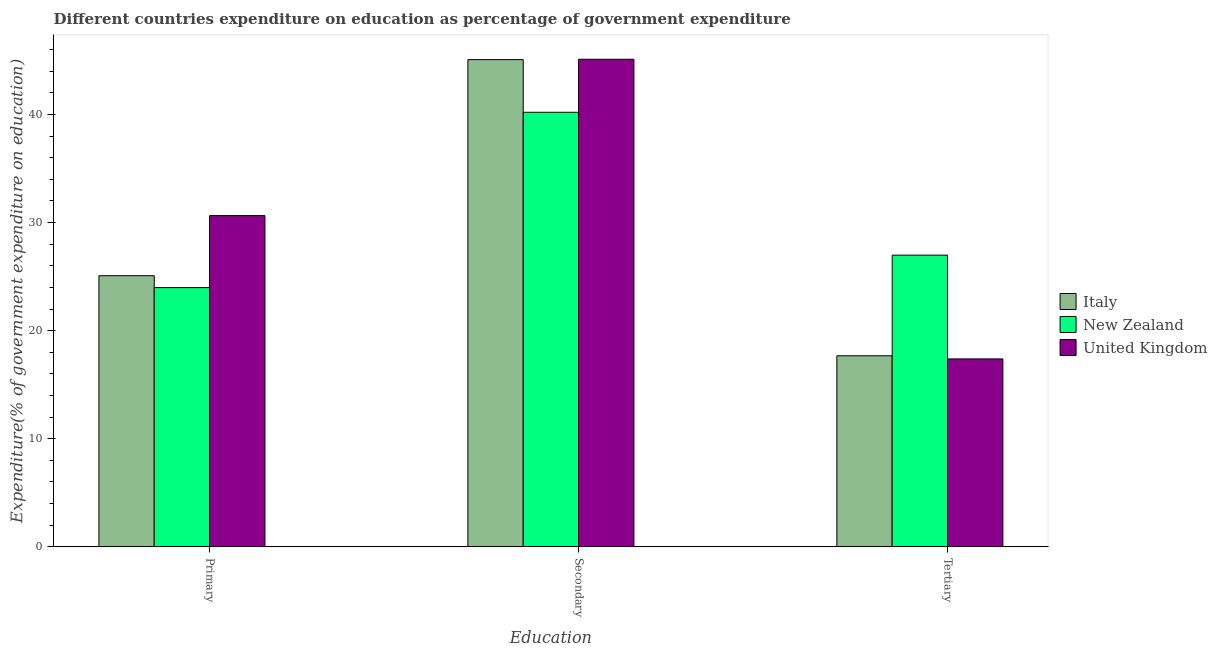How many different coloured bars are there?
Provide a short and direct response. 3. How many groups of bars are there?
Make the answer very short. 3. Are the number of bars on each tick of the X-axis equal?
Give a very brief answer. Yes. What is the label of the 2nd group of bars from the left?
Make the answer very short. Secondary. What is the expenditure on secondary education in United Kingdom?
Ensure brevity in your answer.  45.11. Across all countries, what is the maximum expenditure on secondary education?
Ensure brevity in your answer.  45.11. Across all countries, what is the minimum expenditure on primary education?
Offer a terse response. 23.99. In which country was the expenditure on tertiary education maximum?
Give a very brief answer. New Zealand. In which country was the expenditure on primary education minimum?
Your answer should be compact. New Zealand. What is the total expenditure on secondary education in the graph?
Provide a succinct answer. 130.39. What is the difference between the expenditure on tertiary education in Italy and that in New Zealand?
Ensure brevity in your answer.  -9.31. What is the difference between the expenditure on secondary education in Italy and the expenditure on tertiary education in New Zealand?
Offer a very short reply. 18.09. What is the average expenditure on secondary education per country?
Ensure brevity in your answer.  43.46. What is the difference between the expenditure on primary education and expenditure on tertiary education in Italy?
Provide a short and direct response. 7.41. In how many countries, is the expenditure on primary education greater than 32 %?
Offer a very short reply. 0. What is the ratio of the expenditure on secondary education in United Kingdom to that in New Zealand?
Give a very brief answer. 1.12. Is the difference between the expenditure on secondary education in Italy and United Kingdom greater than the difference between the expenditure on primary education in Italy and United Kingdom?
Your answer should be compact. Yes. What is the difference between the highest and the second highest expenditure on primary education?
Give a very brief answer. 5.56. What is the difference between the highest and the lowest expenditure on secondary education?
Offer a very short reply. 4.91. In how many countries, is the expenditure on primary education greater than the average expenditure on primary education taken over all countries?
Give a very brief answer. 1. Is the sum of the expenditure on secondary education in United Kingdom and Italy greater than the maximum expenditure on tertiary education across all countries?
Your response must be concise. Yes. What does the 3rd bar from the left in Secondary represents?
Make the answer very short. United Kingdom. How many bars are there?
Make the answer very short. 9. Are all the bars in the graph horizontal?
Your answer should be compact. No. How many countries are there in the graph?
Give a very brief answer. 3. What is the difference between two consecutive major ticks on the Y-axis?
Make the answer very short. 10. Does the graph contain any zero values?
Offer a terse response. No. Does the graph contain grids?
Your answer should be very brief. No. How many legend labels are there?
Your answer should be very brief. 3. What is the title of the graph?
Your response must be concise. Different countries expenditure on education as percentage of government expenditure. Does "Argentina" appear as one of the legend labels in the graph?
Provide a succinct answer. No. What is the label or title of the X-axis?
Your response must be concise. Education. What is the label or title of the Y-axis?
Keep it short and to the point. Expenditure(% of government expenditure on education). What is the Expenditure(% of government expenditure on education) of Italy in Primary?
Keep it short and to the point. 25.08. What is the Expenditure(% of government expenditure on education) in New Zealand in Primary?
Your answer should be very brief. 23.99. What is the Expenditure(% of government expenditure on education) of United Kingdom in Primary?
Ensure brevity in your answer.  30.65. What is the Expenditure(% of government expenditure on education) of Italy in Secondary?
Keep it short and to the point. 45.07. What is the Expenditure(% of government expenditure on education) in New Zealand in Secondary?
Offer a very short reply. 40.2. What is the Expenditure(% of government expenditure on education) of United Kingdom in Secondary?
Provide a short and direct response. 45.11. What is the Expenditure(% of government expenditure on education) in Italy in Tertiary?
Your answer should be compact. 17.68. What is the Expenditure(% of government expenditure on education) in New Zealand in Tertiary?
Make the answer very short. 26.99. What is the Expenditure(% of government expenditure on education) of United Kingdom in Tertiary?
Ensure brevity in your answer.  17.39. Across all Education, what is the maximum Expenditure(% of government expenditure on education) in Italy?
Offer a very short reply. 45.07. Across all Education, what is the maximum Expenditure(% of government expenditure on education) in New Zealand?
Give a very brief answer. 40.2. Across all Education, what is the maximum Expenditure(% of government expenditure on education) of United Kingdom?
Keep it short and to the point. 45.11. Across all Education, what is the minimum Expenditure(% of government expenditure on education) in Italy?
Provide a succinct answer. 17.68. Across all Education, what is the minimum Expenditure(% of government expenditure on education) of New Zealand?
Your answer should be compact. 23.99. Across all Education, what is the minimum Expenditure(% of government expenditure on education) in United Kingdom?
Your response must be concise. 17.39. What is the total Expenditure(% of government expenditure on education) of Italy in the graph?
Your answer should be very brief. 87.84. What is the total Expenditure(% of government expenditure on education) of New Zealand in the graph?
Your answer should be compact. 91.17. What is the total Expenditure(% of government expenditure on education) of United Kingdom in the graph?
Make the answer very short. 93.14. What is the difference between the Expenditure(% of government expenditure on education) of Italy in Primary and that in Secondary?
Provide a short and direct response. -19.99. What is the difference between the Expenditure(% of government expenditure on education) of New Zealand in Primary and that in Secondary?
Make the answer very short. -16.22. What is the difference between the Expenditure(% of government expenditure on education) of United Kingdom in Primary and that in Secondary?
Provide a succinct answer. -14.46. What is the difference between the Expenditure(% of government expenditure on education) in Italy in Primary and that in Tertiary?
Provide a short and direct response. 7.41. What is the difference between the Expenditure(% of government expenditure on education) of United Kingdom in Primary and that in Tertiary?
Your response must be concise. 13.26. What is the difference between the Expenditure(% of government expenditure on education) of Italy in Secondary and that in Tertiary?
Offer a very short reply. 27.4. What is the difference between the Expenditure(% of government expenditure on education) in New Zealand in Secondary and that in Tertiary?
Give a very brief answer. 13.22. What is the difference between the Expenditure(% of government expenditure on education) in United Kingdom in Secondary and that in Tertiary?
Offer a very short reply. 27.72. What is the difference between the Expenditure(% of government expenditure on education) in Italy in Primary and the Expenditure(% of government expenditure on education) in New Zealand in Secondary?
Provide a short and direct response. -15.12. What is the difference between the Expenditure(% of government expenditure on education) in Italy in Primary and the Expenditure(% of government expenditure on education) in United Kingdom in Secondary?
Keep it short and to the point. -20.02. What is the difference between the Expenditure(% of government expenditure on education) of New Zealand in Primary and the Expenditure(% of government expenditure on education) of United Kingdom in Secondary?
Your answer should be compact. -21.12. What is the difference between the Expenditure(% of government expenditure on education) in Italy in Primary and the Expenditure(% of government expenditure on education) in New Zealand in Tertiary?
Offer a terse response. -1.9. What is the difference between the Expenditure(% of government expenditure on education) of Italy in Primary and the Expenditure(% of government expenditure on education) of United Kingdom in Tertiary?
Give a very brief answer. 7.7. What is the difference between the Expenditure(% of government expenditure on education) in New Zealand in Primary and the Expenditure(% of government expenditure on education) in United Kingdom in Tertiary?
Give a very brief answer. 6.6. What is the difference between the Expenditure(% of government expenditure on education) in Italy in Secondary and the Expenditure(% of government expenditure on education) in New Zealand in Tertiary?
Provide a succinct answer. 18.09. What is the difference between the Expenditure(% of government expenditure on education) in Italy in Secondary and the Expenditure(% of government expenditure on education) in United Kingdom in Tertiary?
Your answer should be compact. 27.69. What is the difference between the Expenditure(% of government expenditure on education) in New Zealand in Secondary and the Expenditure(% of government expenditure on education) in United Kingdom in Tertiary?
Make the answer very short. 22.82. What is the average Expenditure(% of government expenditure on education) in Italy per Education?
Offer a very short reply. 29.28. What is the average Expenditure(% of government expenditure on education) in New Zealand per Education?
Ensure brevity in your answer.  30.39. What is the average Expenditure(% of government expenditure on education) of United Kingdom per Education?
Your answer should be very brief. 31.05. What is the difference between the Expenditure(% of government expenditure on education) of Italy and Expenditure(% of government expenditure on education) of New Zealand in Primary?
Your answer should be very brief. 1.1. What is the difference between the Expenditure(% of government expenditure on education) of Italy and Expenditure(% of government expenditure on education) of United Kingdom in Primary?
Your answer should be very brief. -5.56. What is the difference between the Expenditure(% of government expenditure on education) of New Zealand and Expenditure(% of government expenditure on education) of United Kingdom in Primary?
Offer a terse response. -6.66. What is the difference between the Expenditure(% of government expenditure on education) of Italy and Expenditure(% of government expenditure on education) of New Zealand in Secondary?
Offer a very short reply. 4.87. What is the difference between the Expenditure(% of government expenditure on education) in Italy and Expenditure(% of government expenditure on education) in United Kingdom in Secondary?
Your answer should be compact. -0.03. What is the difference between the Expenditure(% of government expenditure on education) of New Zealand and Expenditure(% of government expenditure on education) of United Kingdom in Secondary?
Give a very brief answer. -4.91. What is the difference between the Expenditure(% of government expenditure on education) in Italy and Expenditure(% of government expenditure on education) in New Zealand in Tertiary?
Give a very brief answer. -9.31. What is the difference between the Expenditure(% of government expenditure on education) in Italy and Expenditure(% of government expenditure on education) in United Kingdom in Tertiary?
Offer a very short reply. 0.29. What is the difference between the Expenditure(% of government expenditure on education) of New Zealand and Expenditure(% of government expenditure on education) of United Kingdom in Tertiary?
Give a very brief answer. 9.6. What is the ratio of the Expenditure(% of government expenditure on education) of Italy in Primary to that in Secondary?
Provide a short and direct response. 0.56. What is the ratio of the Expenditure(% of government expenditure on education) of New Zealand in Primary to that in Secondary?
Offer a very short reply. 0.6. What is the ratio of the Expenditure(% of government expenditure on education) in United Kingdom in Primary to that in Secondary?
Keep it short and to the point. 0.68. What is the ratio of the Expenditure(% of government expenditure on education) in Italy in Primary to that in Tertiary?
Ensure brevity in your answer.  1.42. What is the ratio of the Expenditure(% of government expenditure on education) of New Zealand in Primary to that in Tertiary?
Your answer should be compact. 0.89. What is the ratio of the Expenditure(% of government expenditure on education) in United Kingdom in Primary to that in Tertiary?
Make the answer very short. 1.76. What is the ratio of the Expenditure(% of government expenditure on education) of Italy in Secondary to that in Tertiary?
Your answer should be very brief. 2.55. What is the ratio of the Expenditure(% of government expenditure on education) of New Zealand in Secondary to that in Tertiary?
Offer a very short reply. 1.49. What is the ratio of the Expenditure(% of government expenditure on education) of United Kingdom in Secondary to that in Tertiary?
Your answer should be compact. 2.59. What is the difference between the highest and the second highest Expenditure(% of government expenditure on education) in Italy?
Your answer should be very brief. 19.99. What is the difference between the highest and the second highest Expenditure(% of government expenditure on education) of New Zealand?
Provide a succinct answer. 13.22. What is the difference between the highest and the second highest Expenditure(% of government expenditure on education) in United Kingdom?
Provide a short and direct response. 14.46. What is the difference between the highest and the lowest Expenditure(% of government expenditure on education) of Italy?
Keep it short and to the point. 27.4. What is the difference between the highest and the lowest Expenditure(% of government expenditure on education) in New Zealand?
Your response must be concise. 16.22. What is the difference between the highest and the lowest Expenditure(% of government expenditure on education) in United Kingdom?
Make the answer very short. 27.72. 